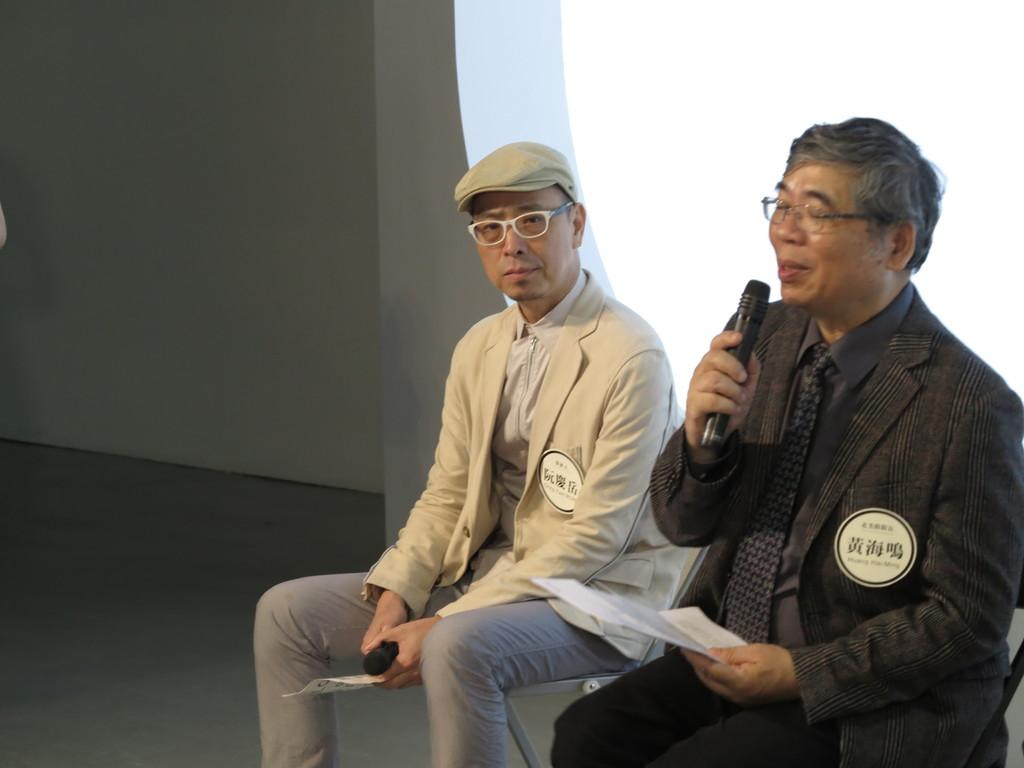How many people are in the image? There are two persons in the image. What are the persons doing in the image? The persons are sitting on chairs. What are the persons holding in the image? The persons are holding objects. What can be seen behind the persons in the image? There is a wall visible in the image. What is visible above the wall in the image? The sky is visible in the image. What type of string is being used by the persons in the image? There is no string present in the image. How many cushions are visible in the image? There is no mention of cushions in the provided facts, so we cannot determine the number of cushions in the image. 